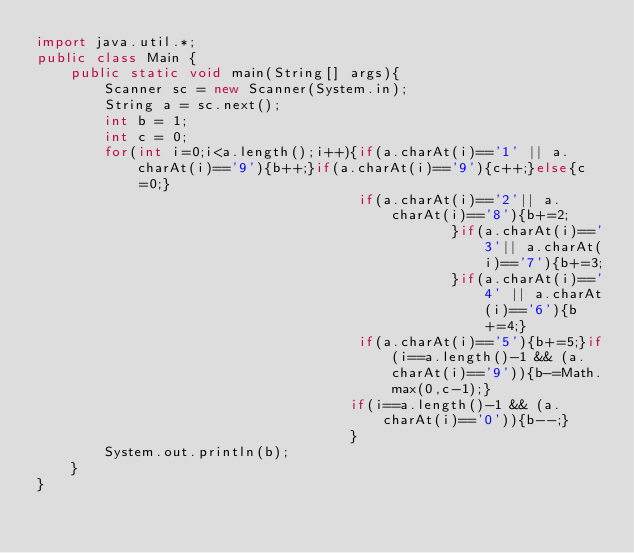<code> <loc_0><loc_0><loc_500><loc_500><_Java_>import java.util.*;
public class Main {
	public static void main(String[] args){
		Scanner sc = new Scanner(System.in);
		String a = sc.next();
		int b = 1;
        int c = 0;
        for(int i=0;i<a.length();i++){if(a.charAt(i)=='1' || a.charAt(i)=='9'){b++;}if(a.charAt(i)=='9'){c++;}else{c=0;}
                                      if(a.charAt(i)=='2'|| a.charAt(i)=='8'){b+=2;
                                                 }if(a.charAt(i)=='3'|| a.charAt(i)=='7'){b+=3;
                                                 }if(a.charAt(i)=='4' || a.charAt(i)=='6'){b+=4;}
                                      if(a.charAt(i)=='5'){b+=5;}if(i==a.length()-1 && (a.charAt(i)=='9')){b-=Math.max(0,c-1);}
                                     if(i==a.length()-1 && (a.charAt(i)=='0')){b--;}
                                     }        
		System.out.println(b);
	}
}
</code> 